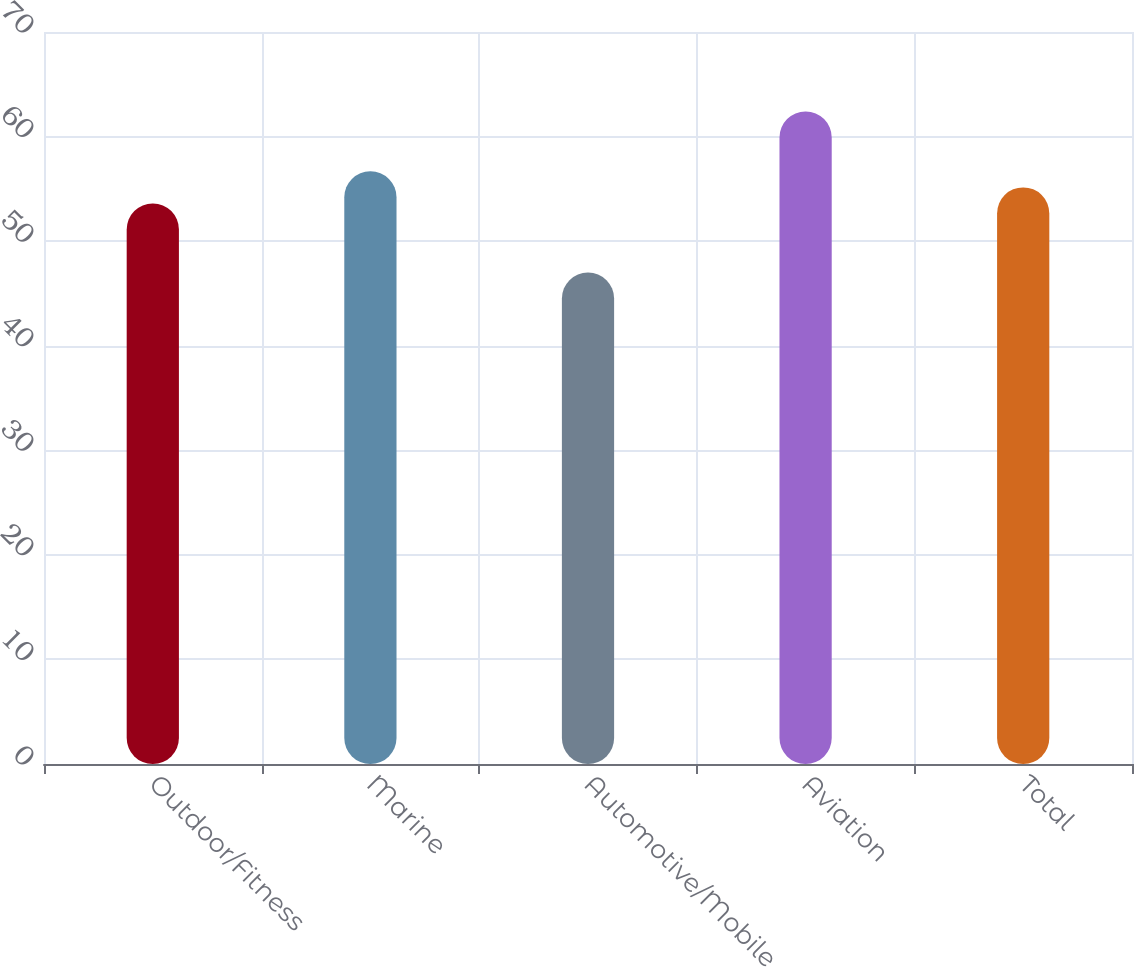Convert chart. <chart><loc_0><loc_0><loc_500><loc_500><bar_chart><fcel>Outdoor/Fitness<fcel>Marine<fcel>Automotive/Mobile<fcel>Aviation<fcel>Total<nl><fcel>53.6<fcel>56.68<fcel>47<fcel>62.4<fcel>55.14<nl></chart> 